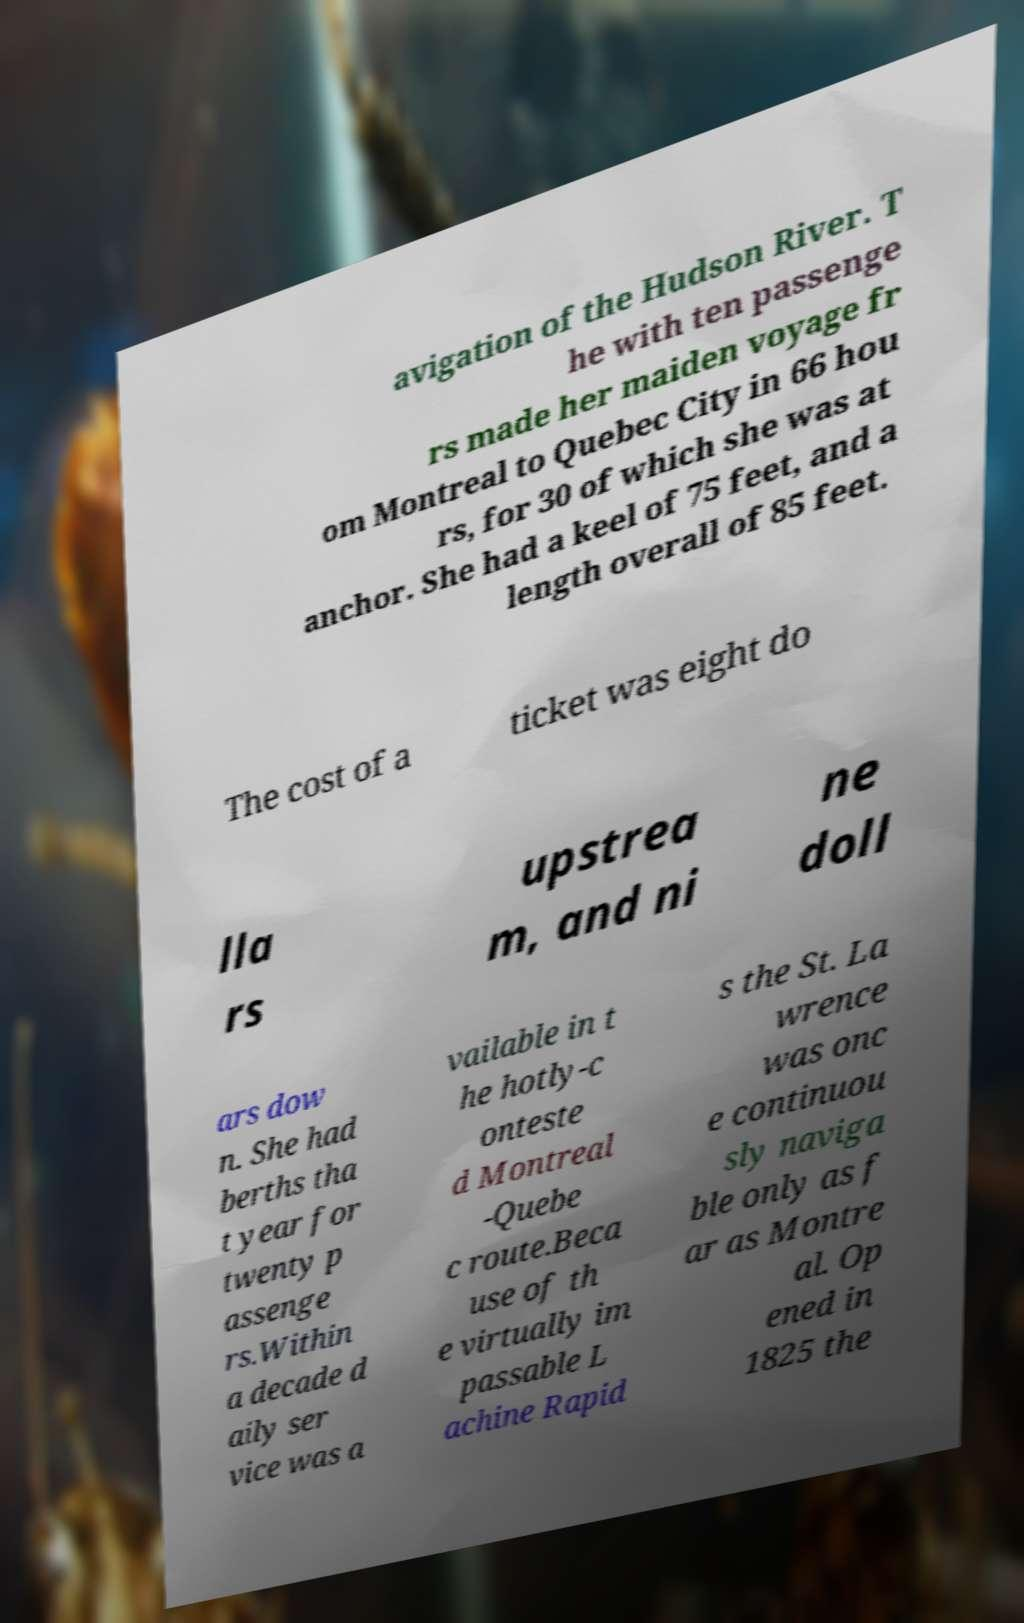What messages or text are displayed in this image? I need them in a readable, typed format. avigation of the Hudson River. T he with ten passenge rs made her maiden voyage fr om Montreal to Quebec City in 66 hou rs, for 30 of which she was at anchor. She had a keel of 75 feet, and a length overall of 85 feet. The cost of a ticket was eight do lla rs upstrea m, and ni ne doll ars dow n. She had berths tha t year for twenty p assenge rs.Within a decade d aily ser vice was a vailable in t he hotly-c onteste d Montreal -Quebe c route.Beca use of th e virtually im passable L achine Rapid s the St. La wrence was onc e continuou sly naviga ble only as f ar as Montre al. Op ened in 1825 the 